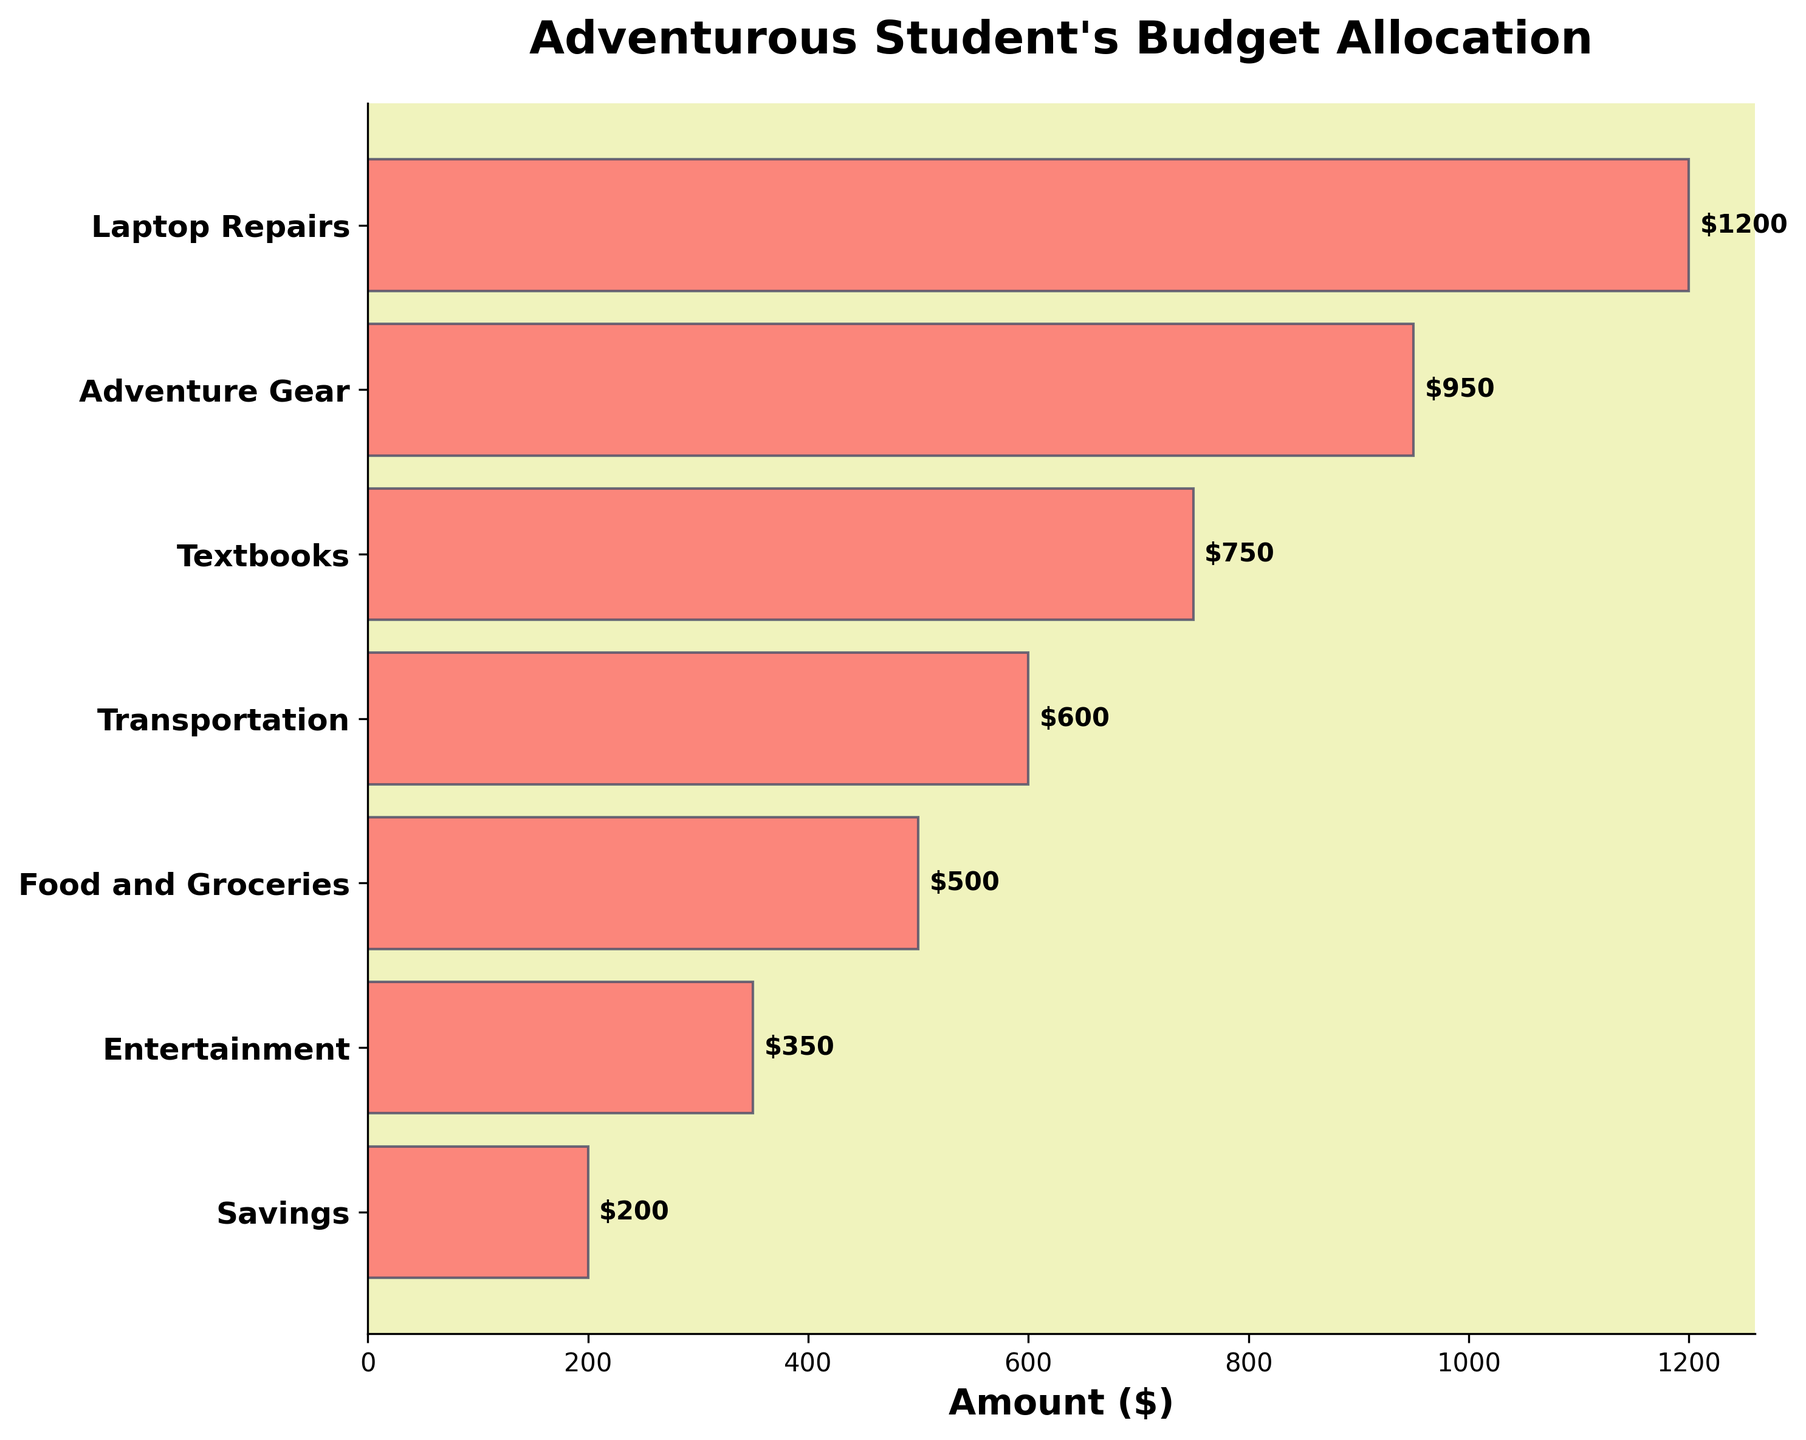Which expense category has the highest amount? The bar with the highest value represents the category with the highest expense. In this case, it is "Laptop Repairs".
Answer: Laptop Repairs What is the title of the chart? The title is displayed at the top of the chart and reads "Adventurous Student's Budget Allocation".
Answer: Adventurous Student's Budget Allocation How much is allocated for Entertainment? The bar labeled "Entertainment" has a value of $350.
Answer: $350 What is the sum of the amounts allocated for Textbooks and Food and Groceries? The amounts for Textbooks and Food and Groceries can be found directly from the chart: $750 + $500 = $1250.
Answer: $1250 By how much does the amount for Adventure Gear exceed the amount for Food and Groceries? The values for Adventure Gear and Food and Groceries are $950 and $500, respectively. Subtract the smaller amount from the larger one: $950 - $500 = $450.
Answer: $450 What is the second highest expense category? The bar immediately below the highest bar (Laptop Repairs) is for Adventure Gear, which is the second highest expense.
Answer: Adventure Gear Which three categories have the smallest allocations? The smallest allocations can be seen at the bottom three bars of the chart: Savings, Entertainment, and Food and Groceries.
Answer: Savings, Entertainment, Food and Groceries If we combine the allocations for Laptop Repairs and Transportation, what percentage of the total budget does it represent? The amounts for Laptop Repairs and Transportation are $1200 and $600, respectively. Their combined sum is $1800. The total amount is $1200 + $950 + $750 + $600 + $500 + $350 + $200 = $4550. The percentage is ($1800 / $4550) * 100 ≈ 39.56%.
Answer: 39.56% What is the difference between the amount allocated to the highest and the lowest categories? The highest allocation is for Laptop Repairs ($1200), and the lowest is for Savings ($200). The difference is $1200 - $200 = $1000.
Answer: $1000 